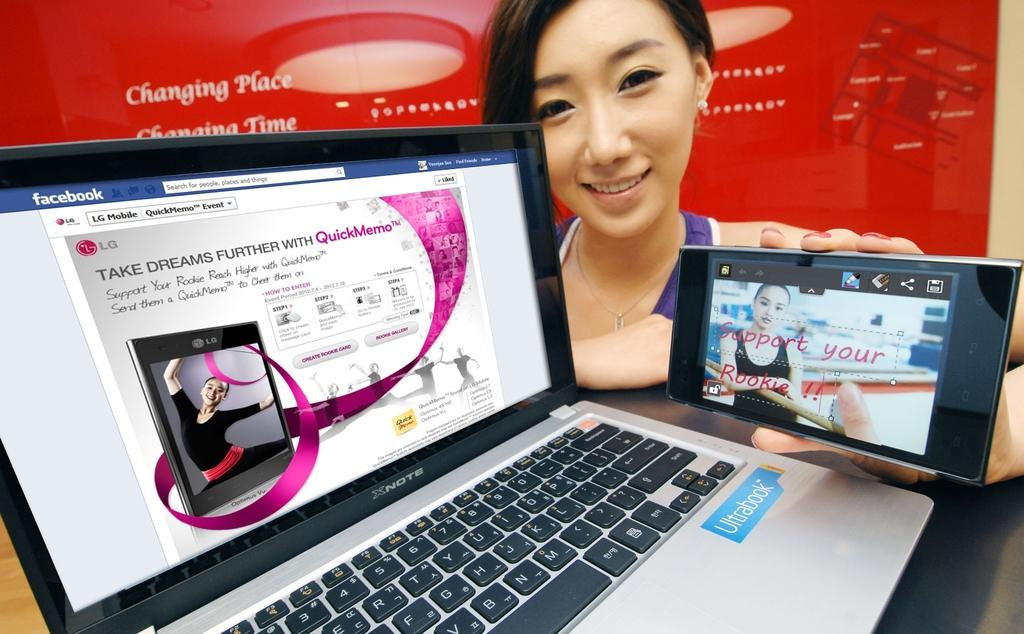<image>
Share a concise interpretation of the image provided. Girl holding phone by the laptop that has a blue sticker with the word Ultrabook. 